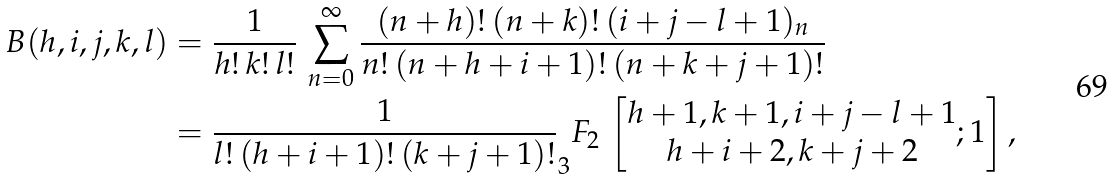<formula> <loc_0><loc_0><loc_500><loc_500>B ( h , i , j , k , l ) & = \frac { 1 } { h ! \, k ! \, l ! } \, \sum _ { n = 0 } ^ { \infty } \frac { ( n + h ) ! \, ( n + k ) ! \, ( i + j - l + 1 ) _ { n } } { n ! \, ( n + h + i + 1 ) ! \, ( n + k + j + 1 ) ! } \\ & = \frac { 1 } { l ! \, ( h + i + 1 ) ! \, ( k + j + 1 ) ! } _ { 3 } F _ { 2 } \, \left [ \begin{matrix} { h + 1 , k + 1 , i + j - l + 1 } \\ { h + i + 2 , k + j + 2 } \end{matrix} ; 1 \right ] ,</formula> 